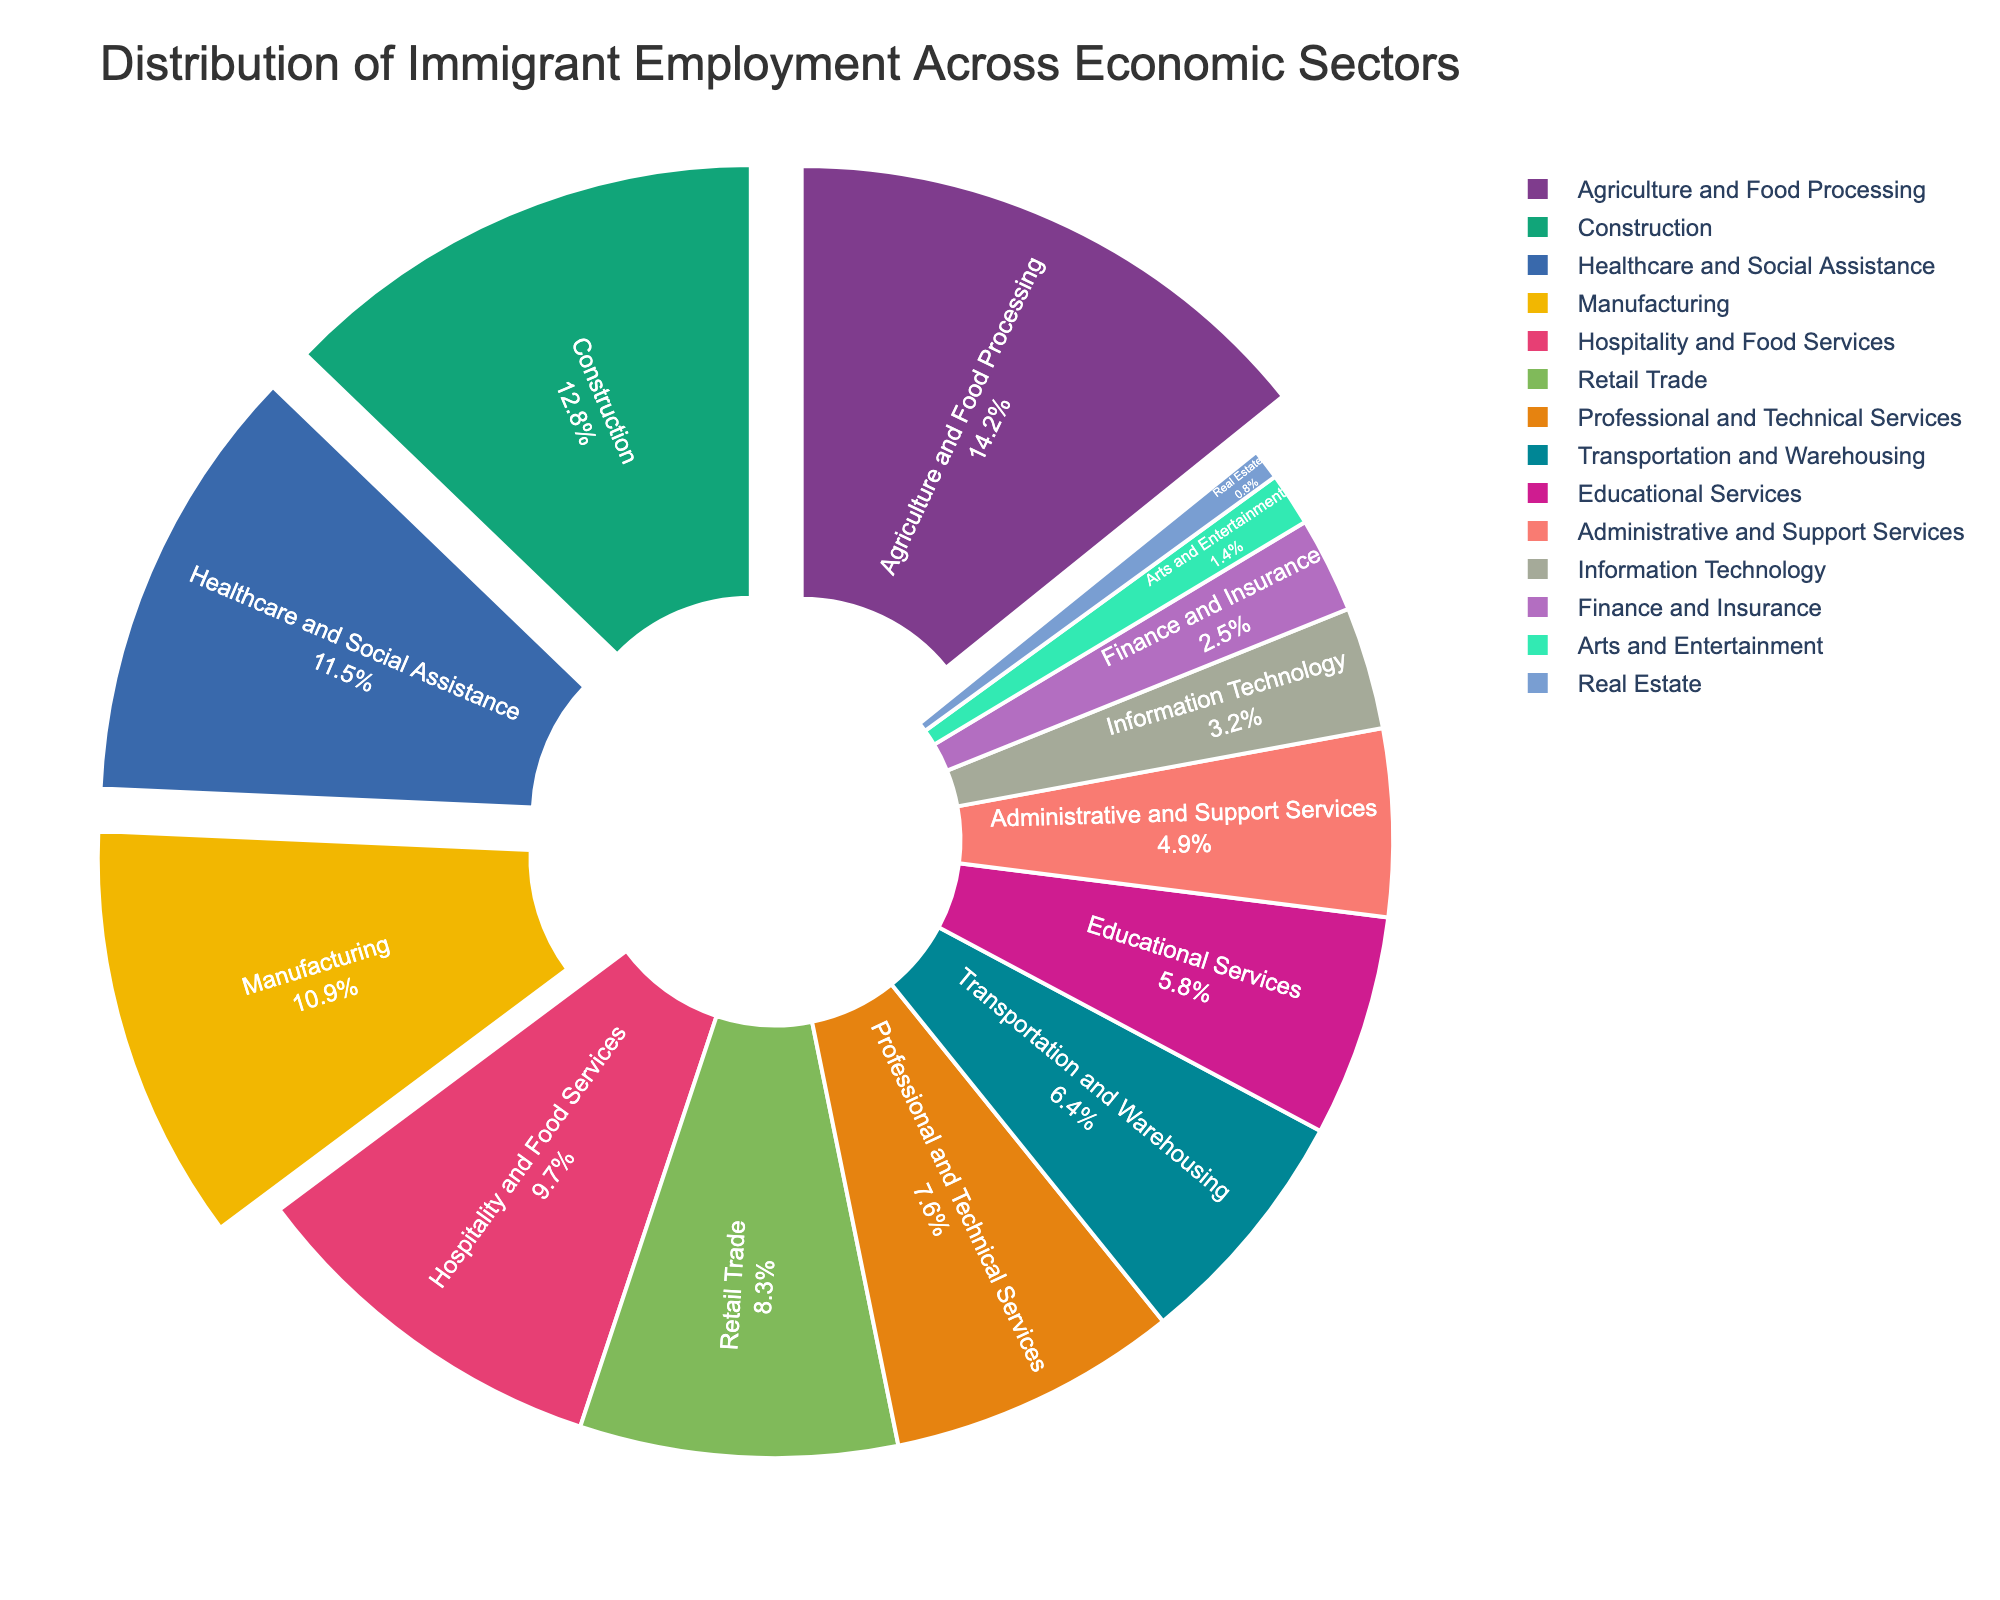Which sector has the highest percentage of immigrant employment? The sector with the highest percentage of immigrant employment is clearly labeled in the pie chart. Locate the largest segment and check its label.
Answer: Agriculture and Food Processing Which sectors have a higher percentage of immigrant employment: Healthcare and Social Assistance or Manufacturing? To determine which sector has a higher percentage of immigrant employment, locate both sectors in the pie chart and compare their percentages. Healthcare and Social Assistance is 11.5%, and Manufacturing is 10.9%, so Healthcare and Social Assistance is higher.
Answer: Healthcare and Social Assistance What is the combined percentage of immigrant employment in Healthcare and Social Assistance, Manufacturing, and Hospitality and Food Services? Add the percentages of the three sectors: Healthcare and Social Assistance (11.5%) + Manufacturing (10.9%) + Hospitality and Food Services (9.7%) = 32.1%.
Answer: 32.1% Which sector has a lower percentage of immigrant employment: Information Technology or Finance and Insurance? Compare the percentages of both sectors: Information Technology is 3.2% and Finance and Insurance is 2.5%, so Finance and Insurance is lower.
Answer: Finance and Insurance Is the percentage of immigrant employment in Construction greater than that in Retail Trade and Professional and Technical Services combined? Add the percentages of Retail Trade (8.3%) and Professional and Technical Services (7.6%) to get 15.9%, then compare with Construction (12.8%). 12.8% is less than 15.9%, so it's not greater.
Answer: No Which sectors have less than 5% of immigrant employment? Identify the sectors with percentages below 5% from the pie chart: Administrative and Support Services (4.9%), Information Technology (3.2%), Finance and Insurance (2.5%), Arts and Entertainment (1.4%), and Real Estate (0.8%).
Answer: Administrative and Support Services, Information Technology, Finance and Insurance, Arts and Entertainment, Real Estate How much greater is the percentage of immigrant employment in Agriculture and Food Processing compared to Real Estate? Subtract the percentage of Real Estate from Agriculture and Food Processing: 14.2% - 0.8% = 13.4%.
Answer: 13.4% What is the second largest sector in terms of immigrant employment percentage? Identify the second largest segment in the pie chart and check its label. Construction is the second largest with 12.8%.
Answer: Construction 